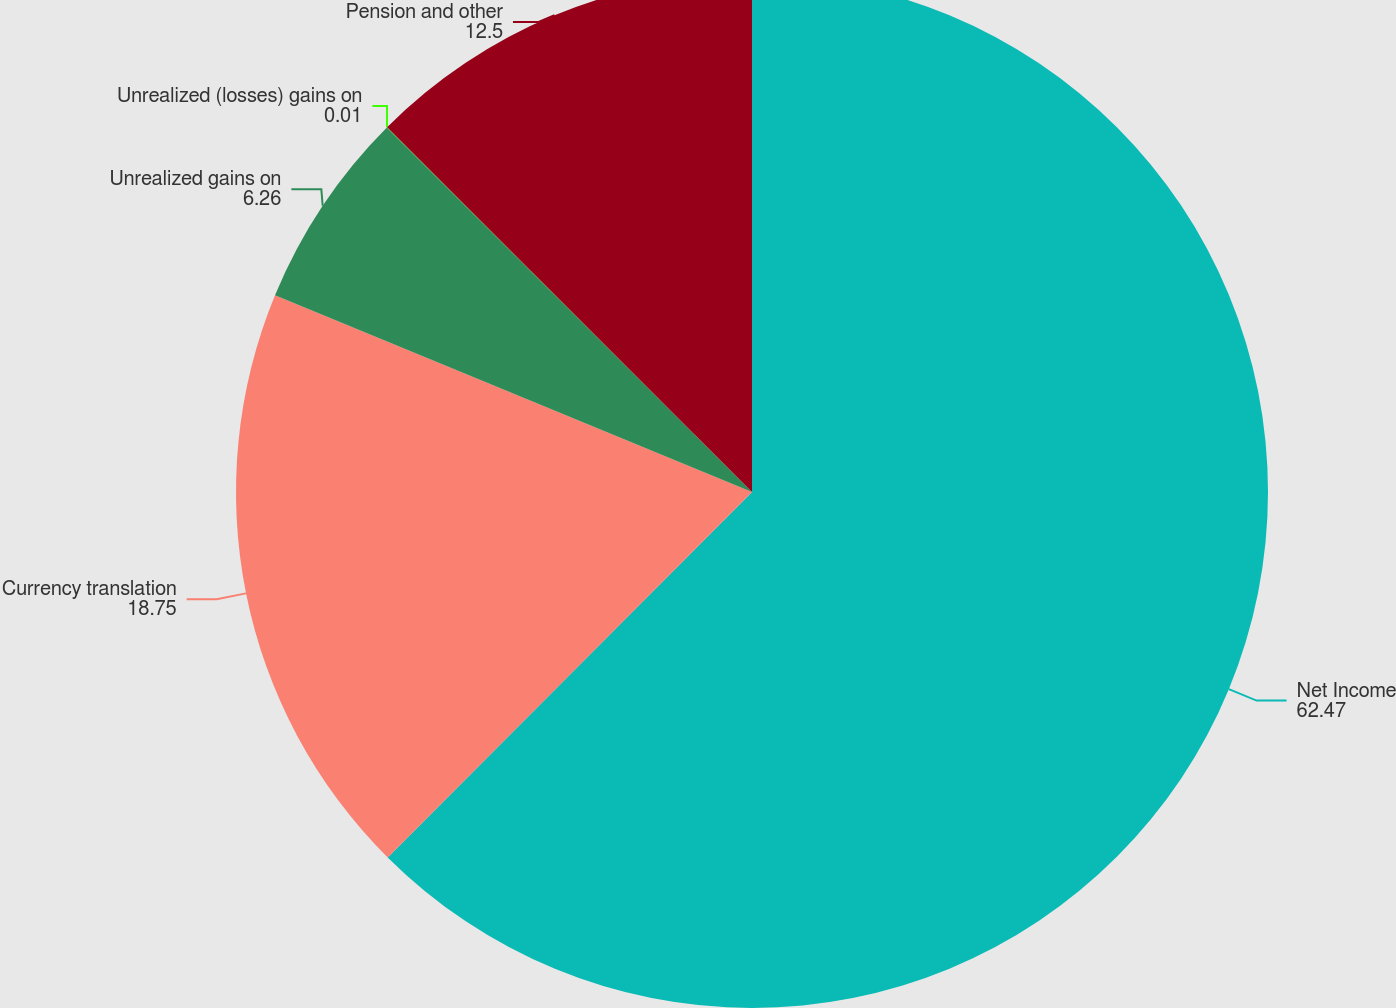<chart> <loc_0><loc_0><loc_500><loc_500><pie_chart><fcel>Net Income<fcel>Currency translation<fcel>Unrealized gains on<fcel>Unrealized (losses) gains on<fcel>Pension and other<nl><fcel>62.47%<fcel>18.75%<fcel>6.26%<fcel>0.01%<fcel>12.5%<nl></chart> 